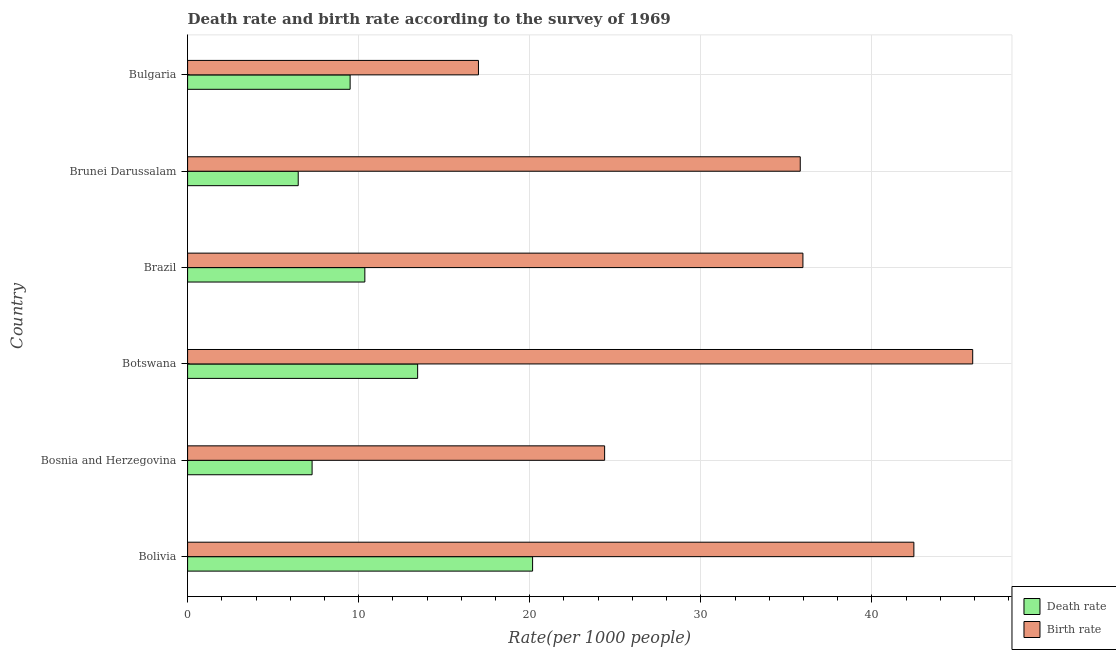How many groups of bars are there?
Give a very brief answer. 6. Are the number of bars per tick equal to the number of legend labels?
Ensure brevity in your answer.  Yes. How many bars are there on the 1st tick from the top?
Your response must be concise. 2. In how many cases, is the number of bars for a given country not equal to the number of legend labels?
Your response must be concise. 0. What is the birth rate in Bosnia and Herzegovina?
Your answer should be compact. 24.38. Across all countries, what is the maximum birth rate?
Your response must be concise. 45.89. Across all countries, what is the minimum death rate?
Your response must be concise. 6.47. In which country was the birth rate maximum?
Give a very brief answer. Botswana. In which country was the birth rate minimum?
Offer a terse response. Bulgaria. What is the total death rate in the graph?
Provide a short and direct response. 67.21. What is the difference between the birth rate in Brunei Darussalam and that in Bulgaria?
Provide a succinct answer. 18.81. What is the difference between the death rate in Bulgaria and the birth rate in Bosnia and Herzegovina?
Your response must be concise. -14.88. What is the average birth rate per country?
Provide a short and direct response. 33.58. What is the difference between the death rate and birth rate in Brunei Darussalam?
Provide a succinct answer. -29.34. In how many countries, is the death rate greater than 36 ?
Keep it short and to the point. 0. What is the ratio of the death rate in Brazil to that in Brunei Darussalam?
Offer a very short reply. 1.6. Is the birth rate in Bolivia less than that in Bulgaria?
Ensure brevity in your answer.  No. What is the difference between the highest and the second highest death rate?
Offer a terse response. 6.72. What is the difference between the highest and the lowest birth rate?
Ensure brevity in your answer.  28.89. In how many countries, is the death rate greater than the average death rate taken over all countries?
Make the answer very short. 2. Is the sum of the birth rate in Bosnia and Herzegovina and Brazil greater than the maximum death rate across all countries?
Keep it short and to the point. Yes. What does the 1st bar from the top in Brazil represents?
Your answer should be very brief. Birth rate. What does the 2nd bar from the bottom in Bulgaria represents?
Provide a short and direct response. Birth rate. Are all the bars in the graph horizontal?
Offer a terse response. Yes. What is the difference between two consecutive major ticks on the X-axis?
Provide a succinct answer. 10. Are the values on the major ticks of X-axis written in scientific E-notation?
Provide a short and direct response. No. How many legend labels are there?
Your response must be concise. 2. How are the legend labels stacked?
Your answer should be compact. Vertical. What is the title of the graph?
Provide a succinct answer. Death rate and birth rate according to the survey of 1969. Does "Time to import" appear as one of the legend labels in the graph?
Your answer should be very brief. No. What is the label or title of the X-axis?
Your answer should be compact. Rate(per 1000 people). What is the Rate(per 1000 people) in Death rate in Bolivia?
Offer a terse response. 20.16. What is the Rate(per 1000 people) in Birth rate in Bolivia?
Ensure brevity in your answer.  42.45. What is the Rate(per 1000 people) of Death rate in Bosnia and Herzegovina?
Your response must be concise. 7.28. What is the Rate(per 1000 people) of Birth rate in Bosnia and Herzegovina?
Give a very brief answer. 24.38. What is the Rate(per 1000 people) in Death rate in Botswana?
Your response must be concise. 13.45. What is the Rate(per 1000 people) of Birth rate in Botswana?
Ensure brevity in your answer.  45.89. What is the Rate(per 1000 people) of Death rate in Brazil?
Offer a very short reply. 10.36. What is the Rate(per 1000 people) in Birth rate in Brazil?
Your answer should be compact. 35.97. What is the Rate(per 1000 people) of Death rate in Brunei Darussalam?
Your answer should be compact. 6.47. What is the Rate(per 1000 people) of Birth rate in Brunei Darussalam?
Provide a succinct answer. 35.81. What is the Rate(per 1000 people) in Death rate in Bulgaria?
Make the answer very short. 9.5. What is the Rate(per 1000 people) of Birth rate in Bulgaria?
Give a very brief answer. 17. Across all countries, what is the maximum Rate(per 1000 people) of Death rate?
Make the answer very short. 20.16. Across all countries, what is the maximum Rate(per 1000 people) of Birth rate?
Your answer should be very brief. 45.89. Across all countries, what is the minimum Rate(per 1000 people) of Death rate?
Ensure brevity in your answer.  6.47. What is the total Rate(per 1000 people) in Death rate in the graph?
Offer a very short reply. 67.21. What is the total Rate(per 1000 people) in Birth rate in the graph?
Give a very brief answer. 201.49. What is the difference between the Rate(per 1000 people) in Death rate in Bolivia and that in Bosnia and Herzegovina?
Give a very brief answer. 12.89. What is the difference between the Rate(per 1000 people) in Birth rate in Bolivia and that in Bosnia and Herzegovina?
Offer a terse response. 18.07. What is the difference between the Rate(per 1000 people) of Death rate in Bolivia and that in Botswana?
Offer a terse response. 6.72. What is the difference between the Rate(per 1000 people) in Birth rate in Bolivia and that in Botswana?
Keep it short and to the point. -3.44. What is the difference between the Rate(per 1000 people) in Death rate in Bolivia and that in Brazil?
Your response must be concise. 9.8. What is the difference between the Rate(per 1000 people) of Birth rate in Bolivia and that in Brazil?
Give a very brief answer. 6.49. What is the difference between the Rate(per 1000 people) in Death rate in Bolivia and that in Brunei Darussalam?
Give a very brief answer. 13.7. What is the difference between the Rate(per 1000 people) in Birth rate in Bolivia and that in Brunei Darussalam?
Offer a very short reply. 6.64. What is the difference between the Rate(per 1000 people) of Death rate in Bolivia and that in Bulgaria?
Make the answer very short. 10.66. What is the difference between the Rate(per 1000 people) of Birth rate in Bolivia and that in Bulgaria?
Offer a terse response. 25.45. What is the difference between the Rate(per 1000 people) of Death rate in Bosnia and Herzegovina and that in Botswana?
Offer a very short reply. -6.17. What is the difference between the Rate(per 1000 people) in Birth rate in Bosnia and Herzegovina and that in Botswana?
Offer a very short reply. -21.51. What is the difference between the Rate(per 1000 people) in Death rate in Bosnia and Herzegovina and that in Brazil?
Make the answer very short. -3.08. What is the difference between the Rate(per 1000 people) in Birth rate in Bosnia and Herzegovina and that in Brazil?
Offer a very short reply. -11.59. What is the difference between the Rate(per 1000 people) in Death rate in Bosnia and Herzegovina and that in Brunei Darussalam?
Ensure brevity in your answer.  0.81. What is the difference between the Rate(per 1000 people) in Birth rate in Bosnia and Herzegovina and that in Brunei Darussalam?
Your answer should be compact. -11.43. What is the difference between the Rate(per 1000 people) in Death rate in Bosnia and Herzegovina and that in Bulgaria?
Provide a succinct answer. -2.22. What is the difference between the Rate(per 1000 people) of Birth rate in Bosnia and Herzegovina and that in Bulgaria?
Give a very brief answer. 7.38. What is the difference between the Rate(per 1000 people) of Death rate in Botswana and that in Brazil?
Your response must be concise. 3.09. What is the difference between the Rate(per 1000 people) of Birth rate in Botswana and that in Brazil?
Your answer should be compact. 9.92. What is the difference between the Rate(per 1000 people) of Death rate in Botswana and that in Brunei Darussalam?
Give a very brief answer. 6.98. What is the difference between the Rate(per 1000 people) of Birth rate in Botswana and that in Brunei Darussalam?
Ensure brevity in your answer.  10.08. What is the difference between the Rate(per 1000 people) of Death rate in Botswana and that in Bulgaria?
Your answer should be very brief. 3.95. What is the difference between the Rate(per 1000 people) in Birth rate in Botswana and that in Bulgaria?
Give a very brief answer. 28.89. What is the difference between the Rate(per 1000 people) of Death rate in Brazil and that in Brunei Darussalam?
Keep it short and to the point. 3.89. What is the difference between the Rate(per 1000 people) in Birth rate in Brazil and that in Brunei Darussalam?
Keep it short and to the point. 0.16. What is the difference between the Rate(per 1000 people) of Death rate in Brazil and that in Bulgaria?
Offer a terse response. 0.86. What is the difference between the Rate(per 1000 people) of Birth rate in Brazil and that in Bulgaria?
Give a very brief answer. 18.96. What is the difference between the Rate(per 1000 people) in Death rate in Brunei Darussalam and that in Bulgaria?
Your response must be concise. -3.03. What is the difference between the Rate(per 1000 people) in Birth rate in Brunei Darussalam and that in Bulgaria?
Ensure brevity in your answer.  18.81. What is the difference between the Rate(per 1000 people) in Death rate in Bolivia and the Rate(per 1000 people) in Birth rate in Bosnia and Herzegovina?
Ensure brevity in your answer.  -4.21. What is the difference between the Rate(per 1000 people) of Death rate in Bolivia and the Rate(per 1000 people) of Birth rate in Botswana?
Provide a succinct answer. -25.72. What is the difference between the Rate(per 1000 people) of Death rate in Bolivia and the Rate(per 1000 people) of Birth rate in Brazil?
Provide a short and direct response. -15.8. What is the difference between the Rate(per 1000 people) of Death rate in Bolivia and the Rate(per 1000 people) of Birth rate in Brunei Darussalam?
Keep it short and to the point. -15.64. What is the difference between the Rate(per 1000 people) of Death rate in Bolivia and the Rate(per 1000 people) of Birth rate in Bulgaria?
Provide a short and direct response. 3.17. What is the difference between the Rate(per 1000 people) of Death rate in Bosnia and Herzegovina and the Rate(per 1000 people) of Birth rate in Botswana?
Your answer should be very brief. -38.61. What is the difference between the Rate(per 1000 people) in Death rate in Bosnia and Herzegovina and the Rate(per 1000 people) in Birth rate in Brazil?
Provide a succinct answer. -28.69. What is the difference between the Rate(per 1000 people) in Death rate in Bosnia and Herzegovina and the Rate(per 1000 people) in Birth rate in Brunei Darussalam?
Provide a succinct answer. -28.53. What is the difference between the Rate(per 1000 people) in Death rate in Bosnia and Herzegovina and the Rate(per 1000 people) in Birth rate in Bulgaria?
Provide a short and direct response. -9.72. What is the difference between the Rate(per 1000 people) of Death rate in Botswana and the Rate(per 1000 people) of Birth rate in Brazil?
Offer a terse response. -22.52. What is the difference between the Rate(per 1000 people) in Death rate in Botswana and the Rate(per 1000 people) in Birth rate in Brunei Darussalam?
Give a very brief answer. -22.36. What is the difference between the Rate(per 1000 people) in Death rate in Botswana and the Rate(per 1000 people) in Birth rate in Bulgaria?
Give a very brief answer. -3.55. What is the difference between the Rate(per 1000 people) of Death rate in Brazil and the Rate(per 1000 people) of Birth rate in Brunei Darussalam?
Your answer should be very brief. -25.45. What is the difference between the Rate(per 1000 people) in Death rate in Brazil and the Rate(per 1000 people) in Birth rate in Bulgaria?
Ensure brevity in your answer.  -6.64. What is the difference between the Rate(per 1000 people) in Death rate in Brunei Darussalam and the Rate(per 1000 people) in Birth rate in Bulgaria?
Your answer should be compact. -10.53. What is the average Rate(per 1000 people) in Death rate per country?
Make the answer very short. 11.2. What is the average Rate(per 1000 people) in Birth rate per country?
Provide a succinct answer. 33.58. What is the difference between the Rate(per 1000 people) in Death rate and Rate(per 1000 people) in Birth rate in Bolivia?
Offer a very short reply. -22.29. What is the difference between the Rate(per 1000 people) of Death rate and Rate(per 1000 people) of Birth rate in Bosnia and Herzegovina?
Your answer should be very brief. -17.1. What is the difference between the Rate(per 1000 people) in Death rate and Rate(per 1000 people) in Birth rate in Botswana?
Your answer should be compact. -32.44. What is the difference between the Rate(per 1000 people) in Death rate and Rate(per 1000 people) in Birth rate in Brazil?
Provide a succinct answer. -25.61. What is the difference between the Rate(per 1000 people) in Death rate and Rate(per 1000 people) in Birth rate in Brunei Darussalam?
Your answer should be very brief. -29.34. What is the difference between the Rate(per 1000 people) in Death rate and Rate(per 1000 people) in Birth rate in Bulgaria?
Offer a very short reply. -7.5. What is the ratio of the Rate(per 1000 people) of Death rate in Bolivia to that in Bosnia and Herzegovina?
Offer a terse response. 2.77. What is the ratio of the Rate(per 1000 people) in Birth rate in Bolivia to that in Bosnia and Herzegovina?
Keep it short and to the point. 1.74. What is the ratio of the Rate(per 1000 people) of Death rate in Bolivia to that in Botswana?
Your response must be concise. 1.5. What is the ratio of the Rate(per 1000 people) in Birth rate in Bolivia to that in Botswana?
Your answer should be compact. 0.93. What is the ratio of the Rate(per 1000 people) in Death rate in Bolivia to that in Brazil?
Your answer should be very brief. 1.95. What is the ratio of the Rate(per 1000 people) in Birth rate in Bolivia to that in Brazil?
Offer a very short reply. 1.18. What is the ratio of the Rate(per 1000 people) in Death rate in Bolivia to that in Brunei Darussalam?
Offer a terse response. 3.12. What is the ratio of the Rate(per 1000 people) of Birth rate in Bolivia to that in Brunei Darussalam?
Your answer should be very brief. 1.19. What is the ratio of the Rate(per 1000 people) in Death rate in Bolivia to that in Bulgaria?
Provide a short and direct response. 2.12. What is the ratio of the Rate(per 1000 people) of Birth rate in Bolivia to that in Bulgaria?
Offer a very short reply. 2.5. What is the ratio of the Rate(per 1000 people) in Death rate in Bosnia and Herzegovina to that in Botswana?
Your answer should be compact. 0.54. What is the ratio of the Rate(per 1000 people) in Birth rate in Bosnia and Herzegovina to that in Botswana?
Give a very brief answer. 0.53. What is the ratio of the Rate(per 1000 people) in Death rate in Bosnia and Herzegovina to that in Brazil?
Ensure brevity in your answer.  0.7. What is the ratio of the Rate(per 1000 people) in Birth rate in Bosnia and Herzegovina to that in Brazil?
Give a very brief answer. 0.68. What is the ratio of the Rate(per 1000 people) in Death rate in Bosnia and Herzegovina to that in Brunei Darussalam?
Your response must be concise. 1.13. What is the ratio of the Rate(per 1000 people) of Birth rate in Bosnia and Herzegovina to that in Brunei Darussalam?
Provide a succinct answer. 0.68. What is the ratio of the Rate(per 1000 people) of Death rate in Bosnia and Herzegovina to that in Bulgaria?
Keep it short and to the point. 0.77. What is the ratio of the Rate(per 1000 people) of Birth rate in Bosnia and Herzegovina to that in Bulgaria?
Your answer should be compact. 1.43. What is the ratio of the Rate(per 1000 people) of Death rate in Botswana to that in Brazil?
Ensure brevity in your answer.  1.3. What is the ratio of the Rate(per 1000 people) in Birth rate in Botswana to that in Brazil?
Your response must be concise. 1.28. What is the ratio of the Rate(per 1000 people) in Death rate in Botswana to that in Brunei Darussalam?
Your answer should be very brief. 2.08. What is the ratio of the Rate(per 1000 people) in Birth rate in Botswana to that in Brunei Darussalam?
Offer a very short reply. 1.28. What is the ratio of the Rate(per 1000 people) in Death rate in Botswana to that in Bulgaria?
Ensure brevity in your answer.  1.42. What is the ratio of the Rate(per 1000 people) of Birth rate in Botswana to that in Bulgaria?
Offer a terse response. 2.7. What is the ratio of the Rate(per 1000 people) in Death rate in Brazil to that in Brunei Darussalam?
Ensure brevity in your answer.  1.6. What is the ratio of the Rate(per 1000 people) of Death rate in Brazil to that in Bulgaria?
Your answer should be very brief. 1.09. What is the ratio of the Rate(per 1000 people) in Birth rate in Brazil to that in Bulgaria?
Your answer should be compact. 2.12. What is the ratio of the Rate(per 1000 people) of Death rate in Brunei Darussalam to that in Bulgaria?
Offer a very short reply. 0.68. What is the ratio of the Rate(per 1000 people) in Birth rate in Brunei Darussalam to that in Bulgaria?
Your response must be concise. 2.11. What is the difference between the highest and the second highest Rate(per 1000 people) in Death rate?
Provide a succinct answer. 6.72. What is the difference between the highest and the second highest Rate(per 1000 people) in Birth rate?
Provide a succinct answer. 3.44. What is the difference between the highest and the lowest Rate(per 1000 people) in Death rate?
Provide a short and direct response. 13.7. What is the difference between the highest and the lowest Rate(per 1000 people) of Birth rate?
Provide a succinct answer. 28.89. 